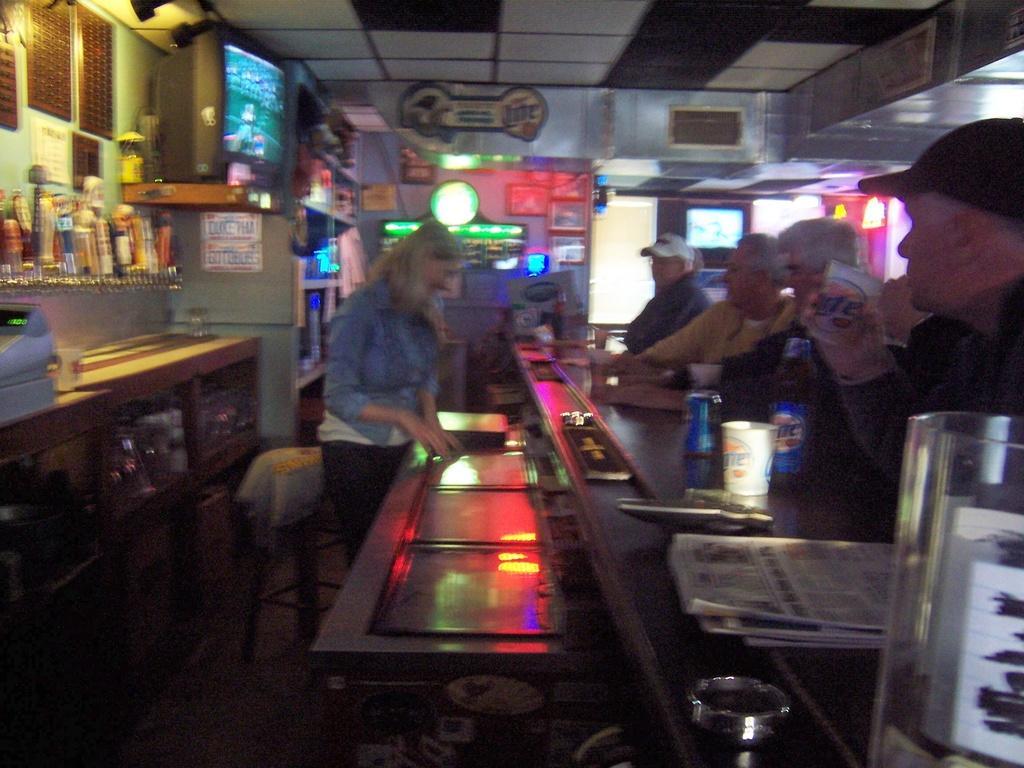Could you give a brief overview of what you see in this image? In this image there are group of people standing, and at the bottom there is a table and on the table there are some papers and bottle, glasses and some objects. And in the background there is a television and some bottles, lights, chairs and some other objects. At the top there is ceiling. 